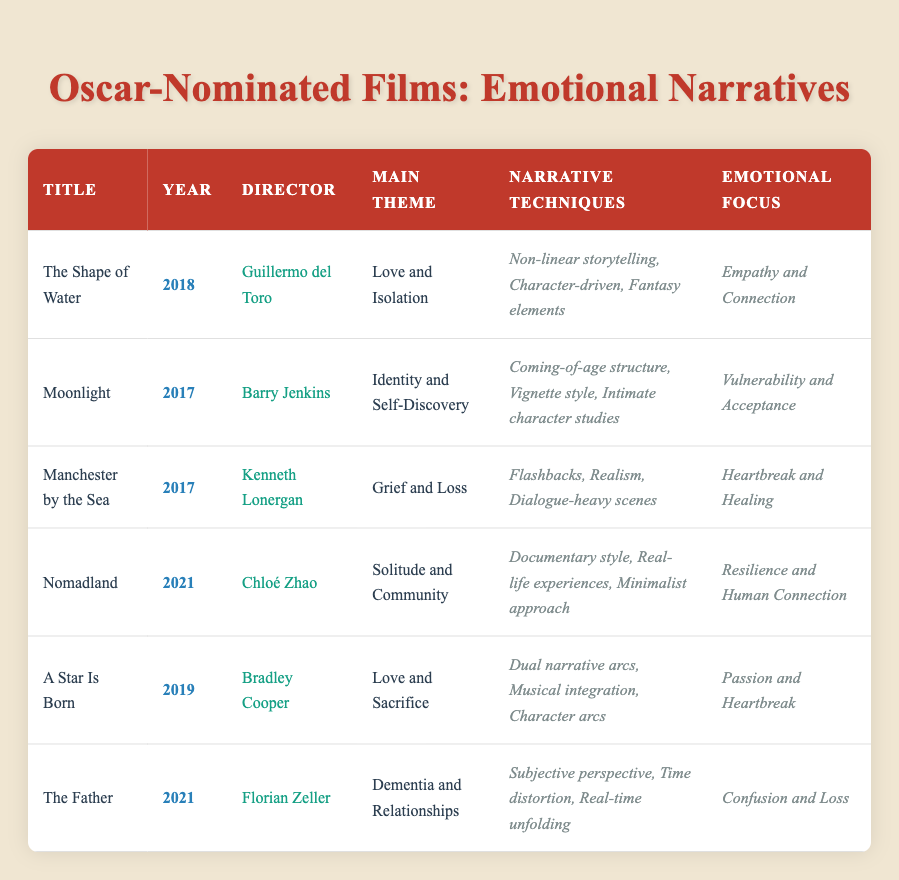What is the main theme of "Moonlight"? The main theme of "Moonlight" is listed in the table as "Identity and Self-Discovery".
Answer: Identity and Self-Discovery Who directed "A Star Is Born"? "A Star Is Born" was directed by Bradley Cooper according to the table.
Answer: Bradley Cooper How many films listed have a main theme related to "Love"? The films with themes related to "Love" are "The Shape of Water" and "A Star Is Born", which gives us a total of 2 films.
Answer: 2 Is "The Father" about grief? "The Father" has the main theme of "Dementia and Relationships," which does not directly indicate grief. Therefore, it is false that it is about grief.
Answer: No What are the narrative techniques used in "Nomadland"? "Nomadland" utilizes narrative techniques such as "Documentary style," "Real-life experiences," and "Minimalist approach," all of which can be found in the table.
Answer: Documentary style, Real-life experiences, Minimalist approach Which film has the emotional focus of "Heartbreak and Healing"? The film with the emotional focus of "Heartbreak and Healing" is "Manchester by the Sea," as indicated in the table.
Answer: Manchester by the Sea Which film directed by Florian Zeller addresses confusion and loss? According to the table, "The Father," directed by Florian Zeller, addresses confusion and loss.
Answer: The Father What is the main theme and emotional focus of "The Shape of Water"? "The Shape of Water" has the main theme of "Love and Isolation" and an emotional focus on "Empathy and Connection," both of which are detailed in the table.
Answer: Love and Isolation, Empathy and Connection How many different narrative techniques are mentioned for "Moonlight"? The narrative techniques for "Moonlight" are "Coming-of-age structure," "Vignette style," and "Intimate character studies," resulting in a total of 3 techniques mentioned.
Answer: 3 What year was "Nomadland" nominated for an Oscar? The table indicates that "Nomadland" was nominated in the year 2021.
Answer: 2021 